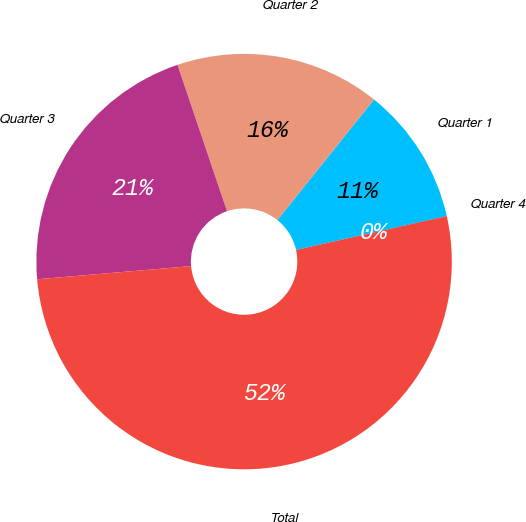<chart> <loc_0><loc_0><loc_500><loc_500><pie_chart><fcel>Quarter 1<fcel>Quarter 2<fcel>Quarter 3<fcel>Total<fcel>Quarter 4<nl><fcel>10.73%<fcel>15.95%<fcel>21.16%<fcel>52.15%<fcel>0.01%<nl></chart> 